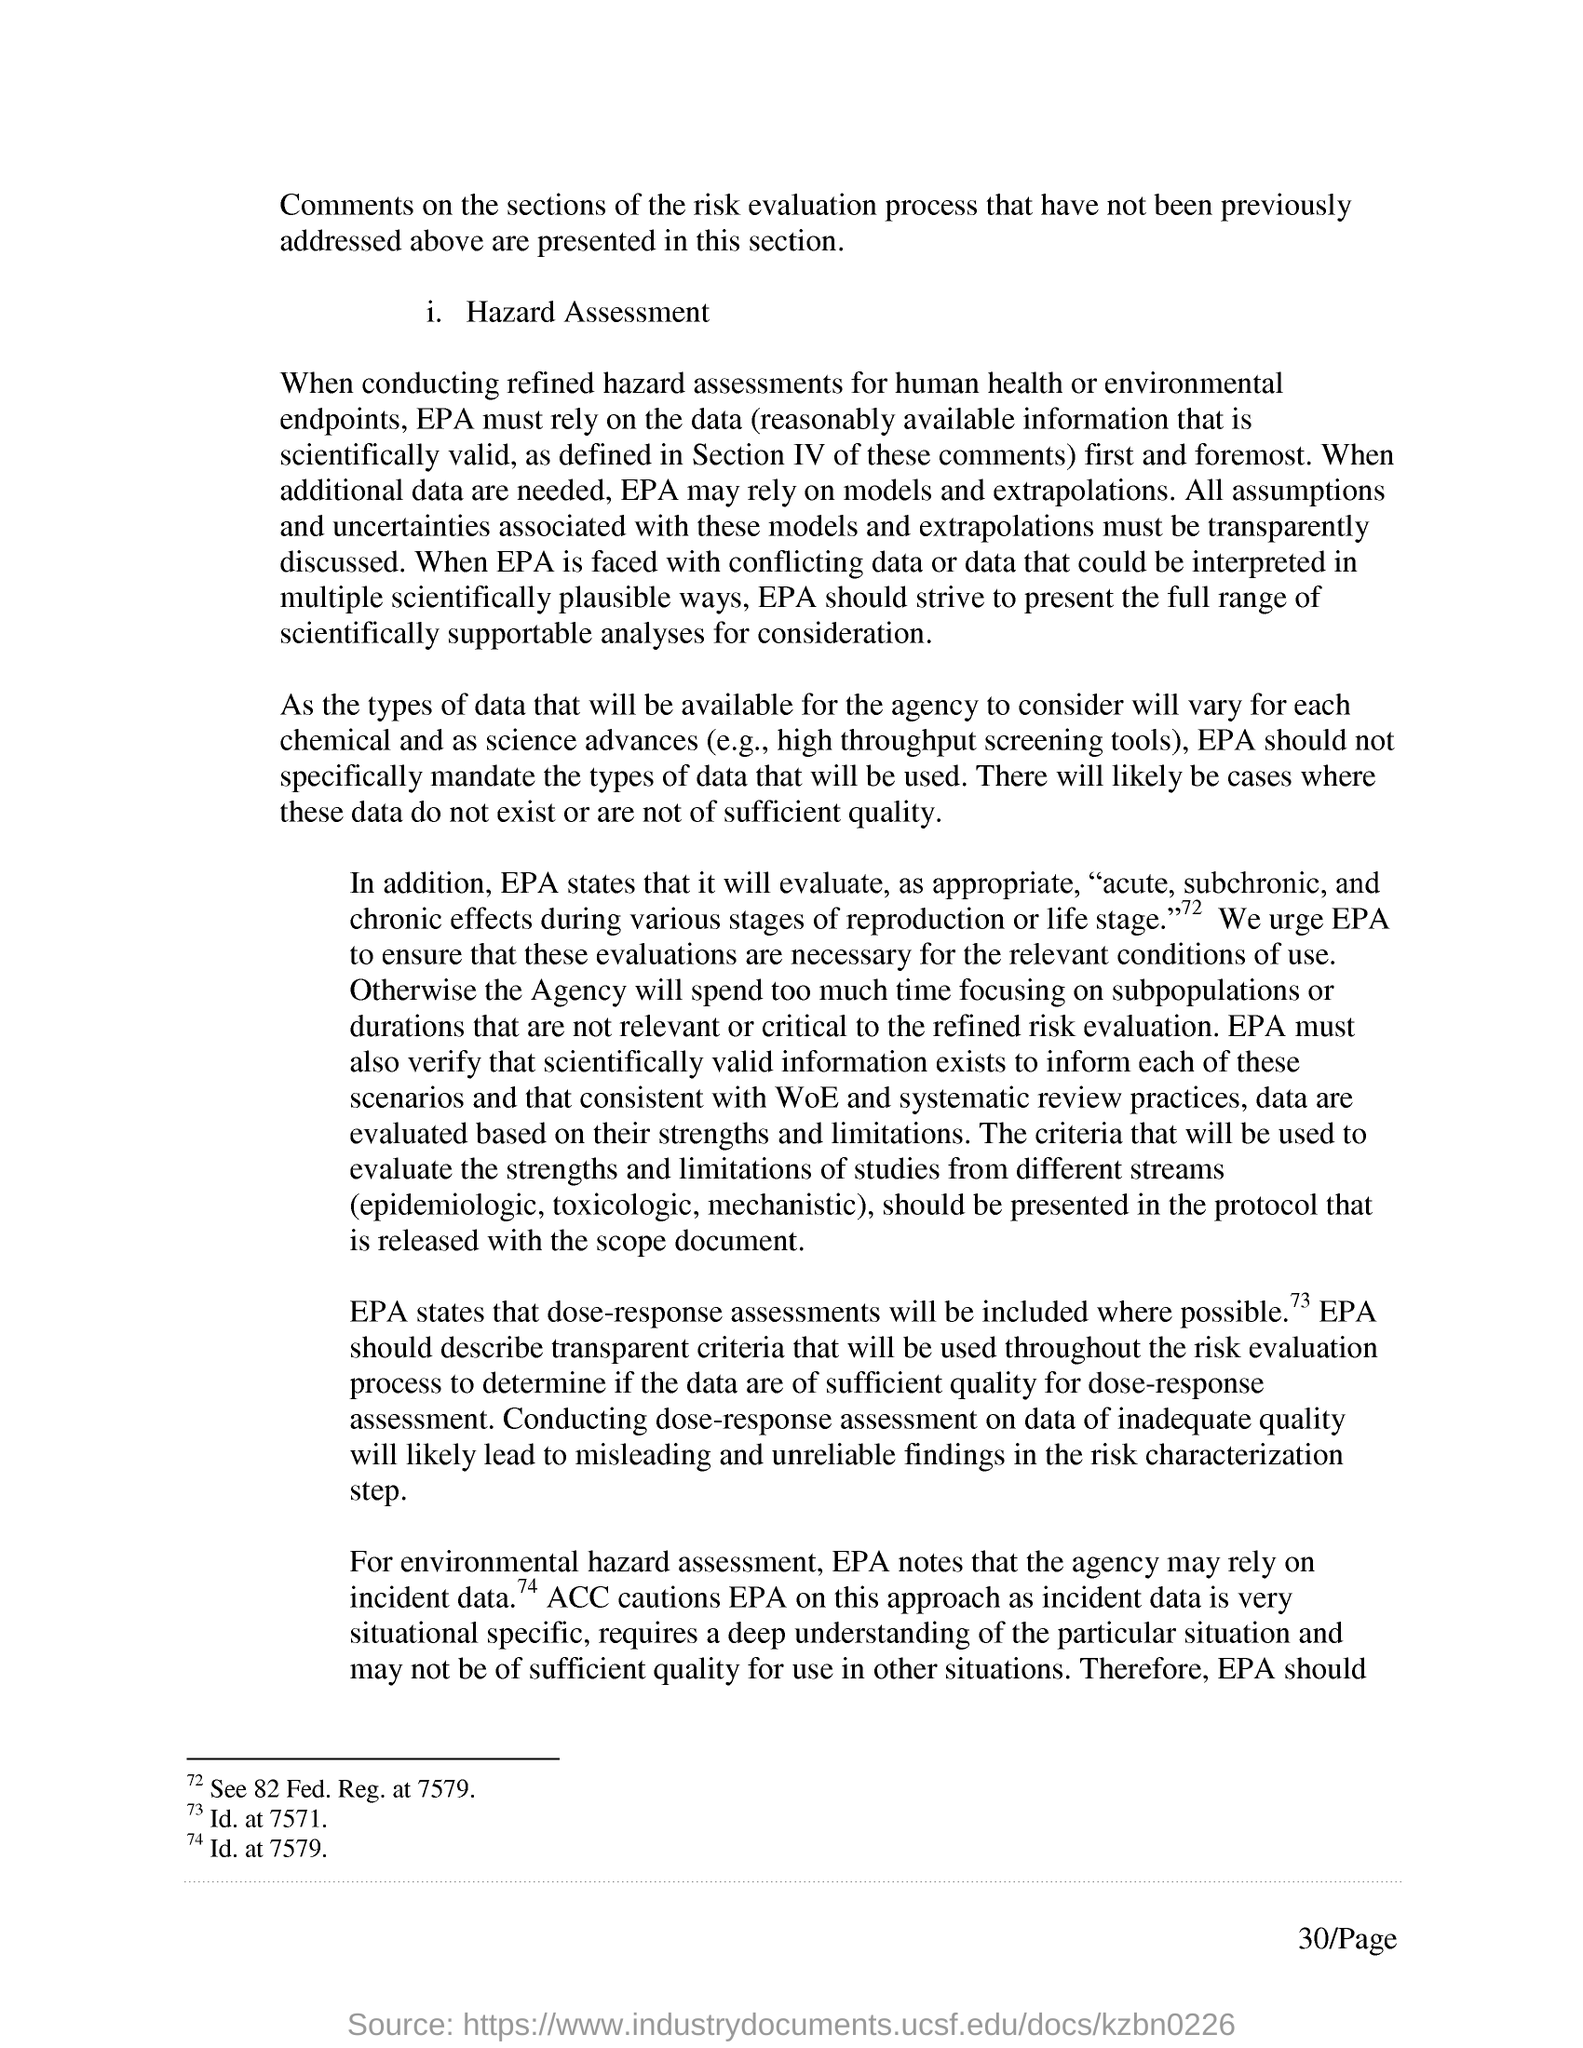On what , the EPA may rely when in need of additional data?
Offer a terse response. On models and extrapolations. What is the page no mentioned in this document?
Your response must be concise. 30. 